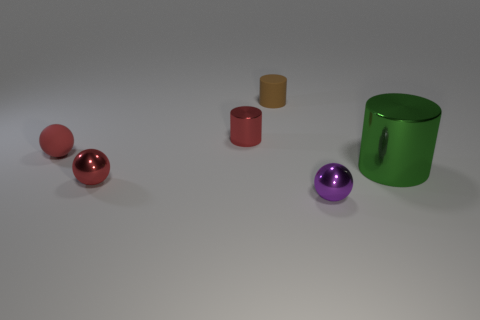How does the lighting in the scene affect the appearance of the objects? The lighting in this scene appears to be coming from above, casting soft, diffused shadows beneath the objects. This highlights the shininess of the reflective objects, such as the red and purple spheres, and the green cylinder, while the matte objects, like the small cylinders, absorb more light and don't reflect it as much, giving them a flatter appearance. 